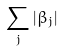Convert formula to latex. <formula><loc_0><loc_0><loc_500><loc_500>\sum _ { j } | \beta _ { j } |</formula> 